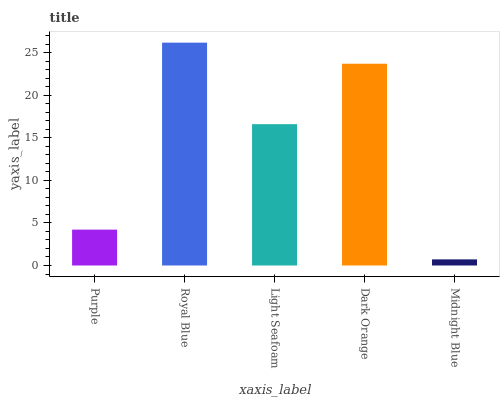Is Midnight Blue the minimum?
Answer yes or no. Yes. Is Royal Blue the maximum?
Answer yes or no. Yes. Is Light Seafoam the minimum?
Answer yes or no. No. Is Light Seafoam the maximum?
Answer yes or no. No. Is Royal Blue greater than Light Seafoam?
Answer yes or no. Yes. Is Light Seafoam less than Royal Blue?
Answer yes or no. Yes. Is Light Seafoam greater than Royal Blue?
Answer yes or no. No. Is Royal Blue less than Light Seafoam?
Answer yes or no. No. Is Light Seafoam the high median?
Answer yes or no. Yes. Is Light Seafoam the low median?
Answer yes or no. Yes. Is Midnight Blue the high median?
Answer yes or no. No. Is Midnight Blue the low median?
Answer yes or no. No. 